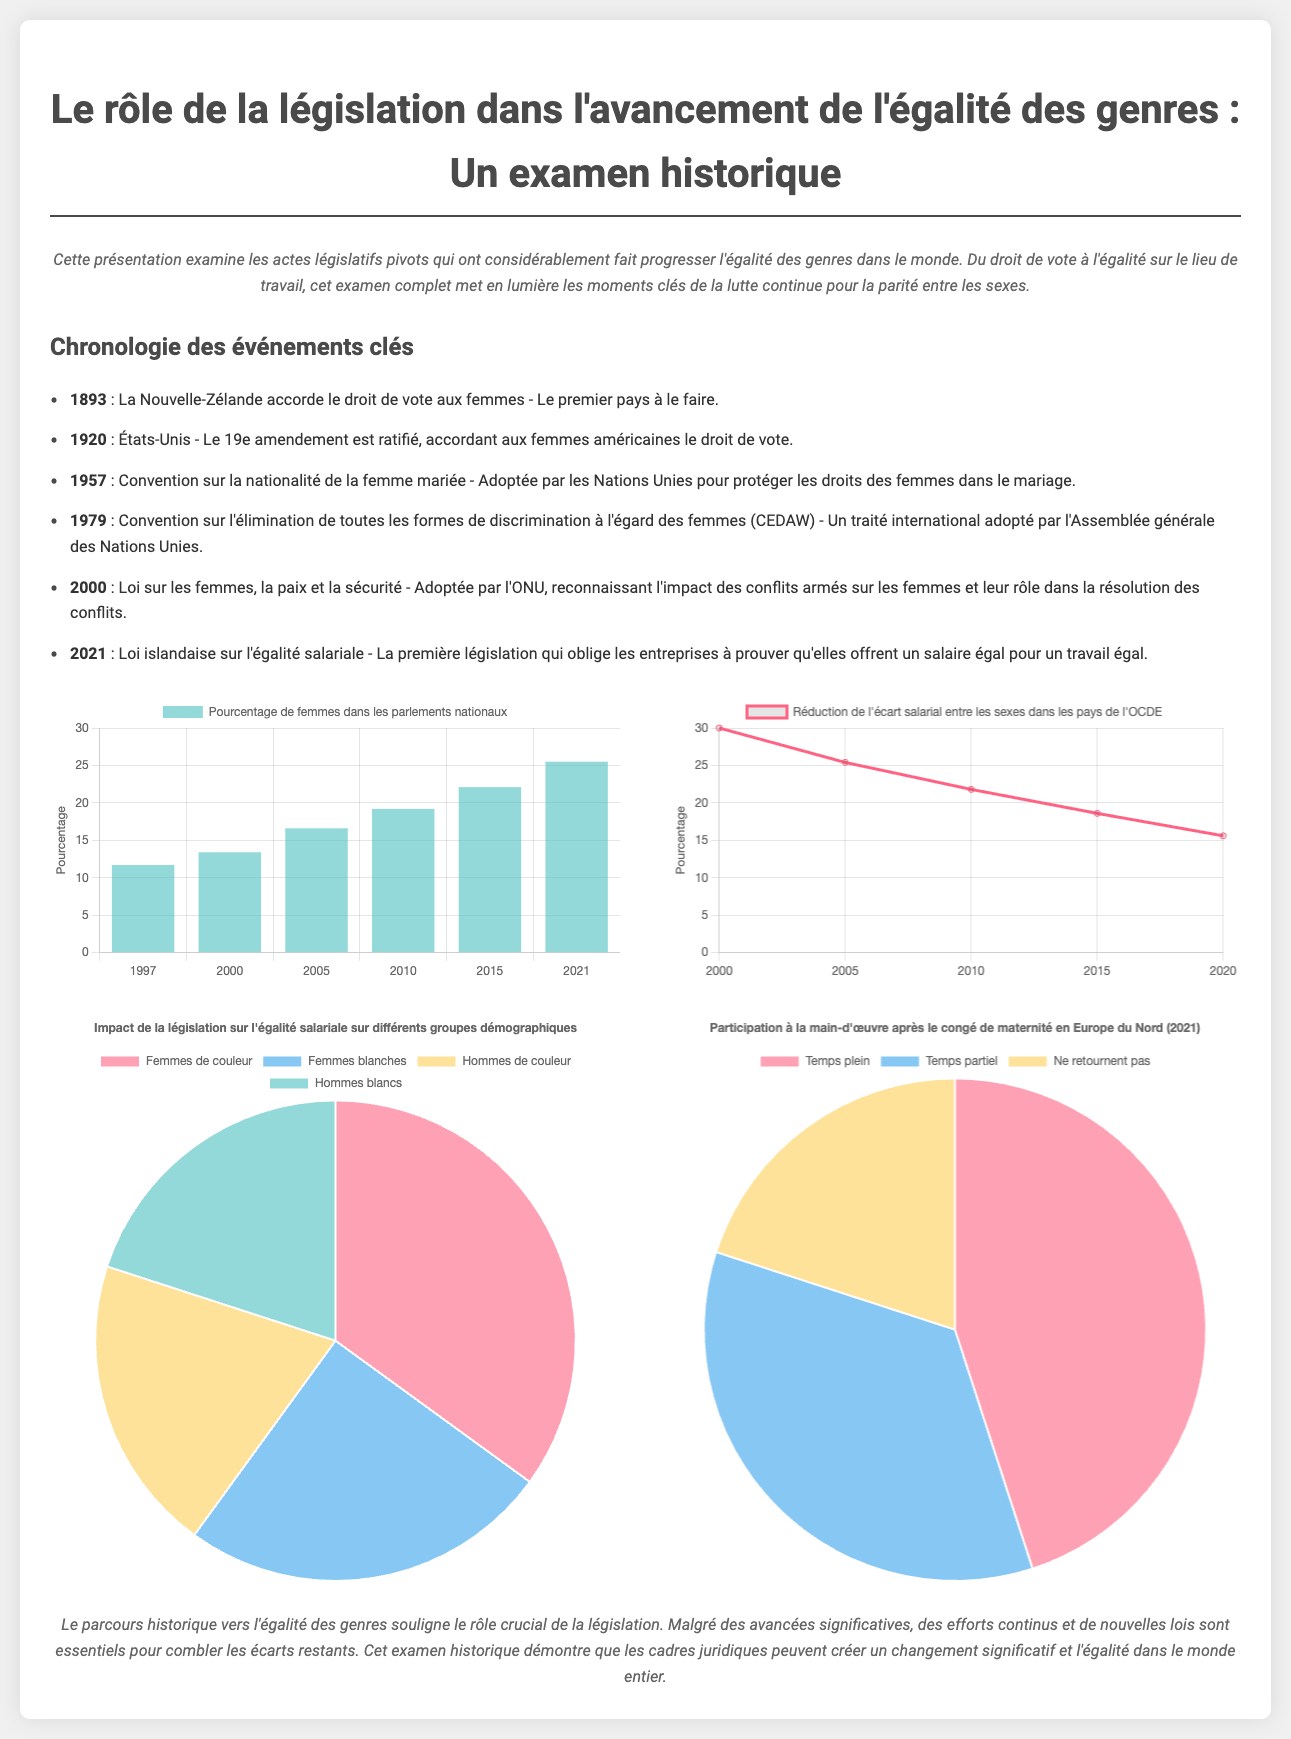Quel est le premier pays à avoir accordé le droit de vote aux femmes ? La Nouvelle-Zélande a accordé le droit de vote aux femmes en 1893, ce qui en fait le premier pays à le faire.
Answer: La Nouvelle-Zélande Quelle année a vu l'adoption de la CEDAW ? La CEDAW, ou Convention sur l'élimination de toutes les formes de discrimination à l'égard des femmes, a été adoptée par l'Assemblée générale des Nations Unies en 1979.
Answer: 1979 Quel était le pourcentage de femmes dans les parlements nationaux en 2021 ? Le graphique indique que le pourcentage de femmes dans les parlements nationaux était de 25,5 % en 2021.
Answer: 25,5 % Quel était l'écart salarial entre les sexes en 2000 dans les pays de l'OCDE ? En 2000, l'écart salarial entre les sexes était de 30 % selon le graphique.
Answer: 30 % Quels groupes sont représentés dans le graphique démographique ? Le graphique démographique montre la répartition en pourcentage de femmes de couleur, femmes blanches, hommes de couleur et hommes blancs.
Answer: Femmes de couleur, femmes blanches, hommes de couleur, hommes blancs Quel pourcentage de femmes ne retournent pas au travail après le congé de maternité en Europe du Nord en 2021 ? Le graphique sur le congé de maternité montre que 20 % des femmes ne retournent pas au travail.
Answer: 20 % Comment s'appelle la loi islandaise qui a été adoptée en 2021 ? La loi adoptée en 2021 qui oblige les entreprises à prouver qu'elles offrent un salaire égal pour un travail égal est la loi islandaise sur l'égalité salariale.
Answer: Loi islandaise sur l'égalité salariale Quel est le titre de cette présentation ? Le titre de la présentation indique qu'elle porte sur le rôle de la législation dans l'avancement de l'égalité des genres.
Answer: Le rôle de la législation dans l'avancement de l'égalité des genres 